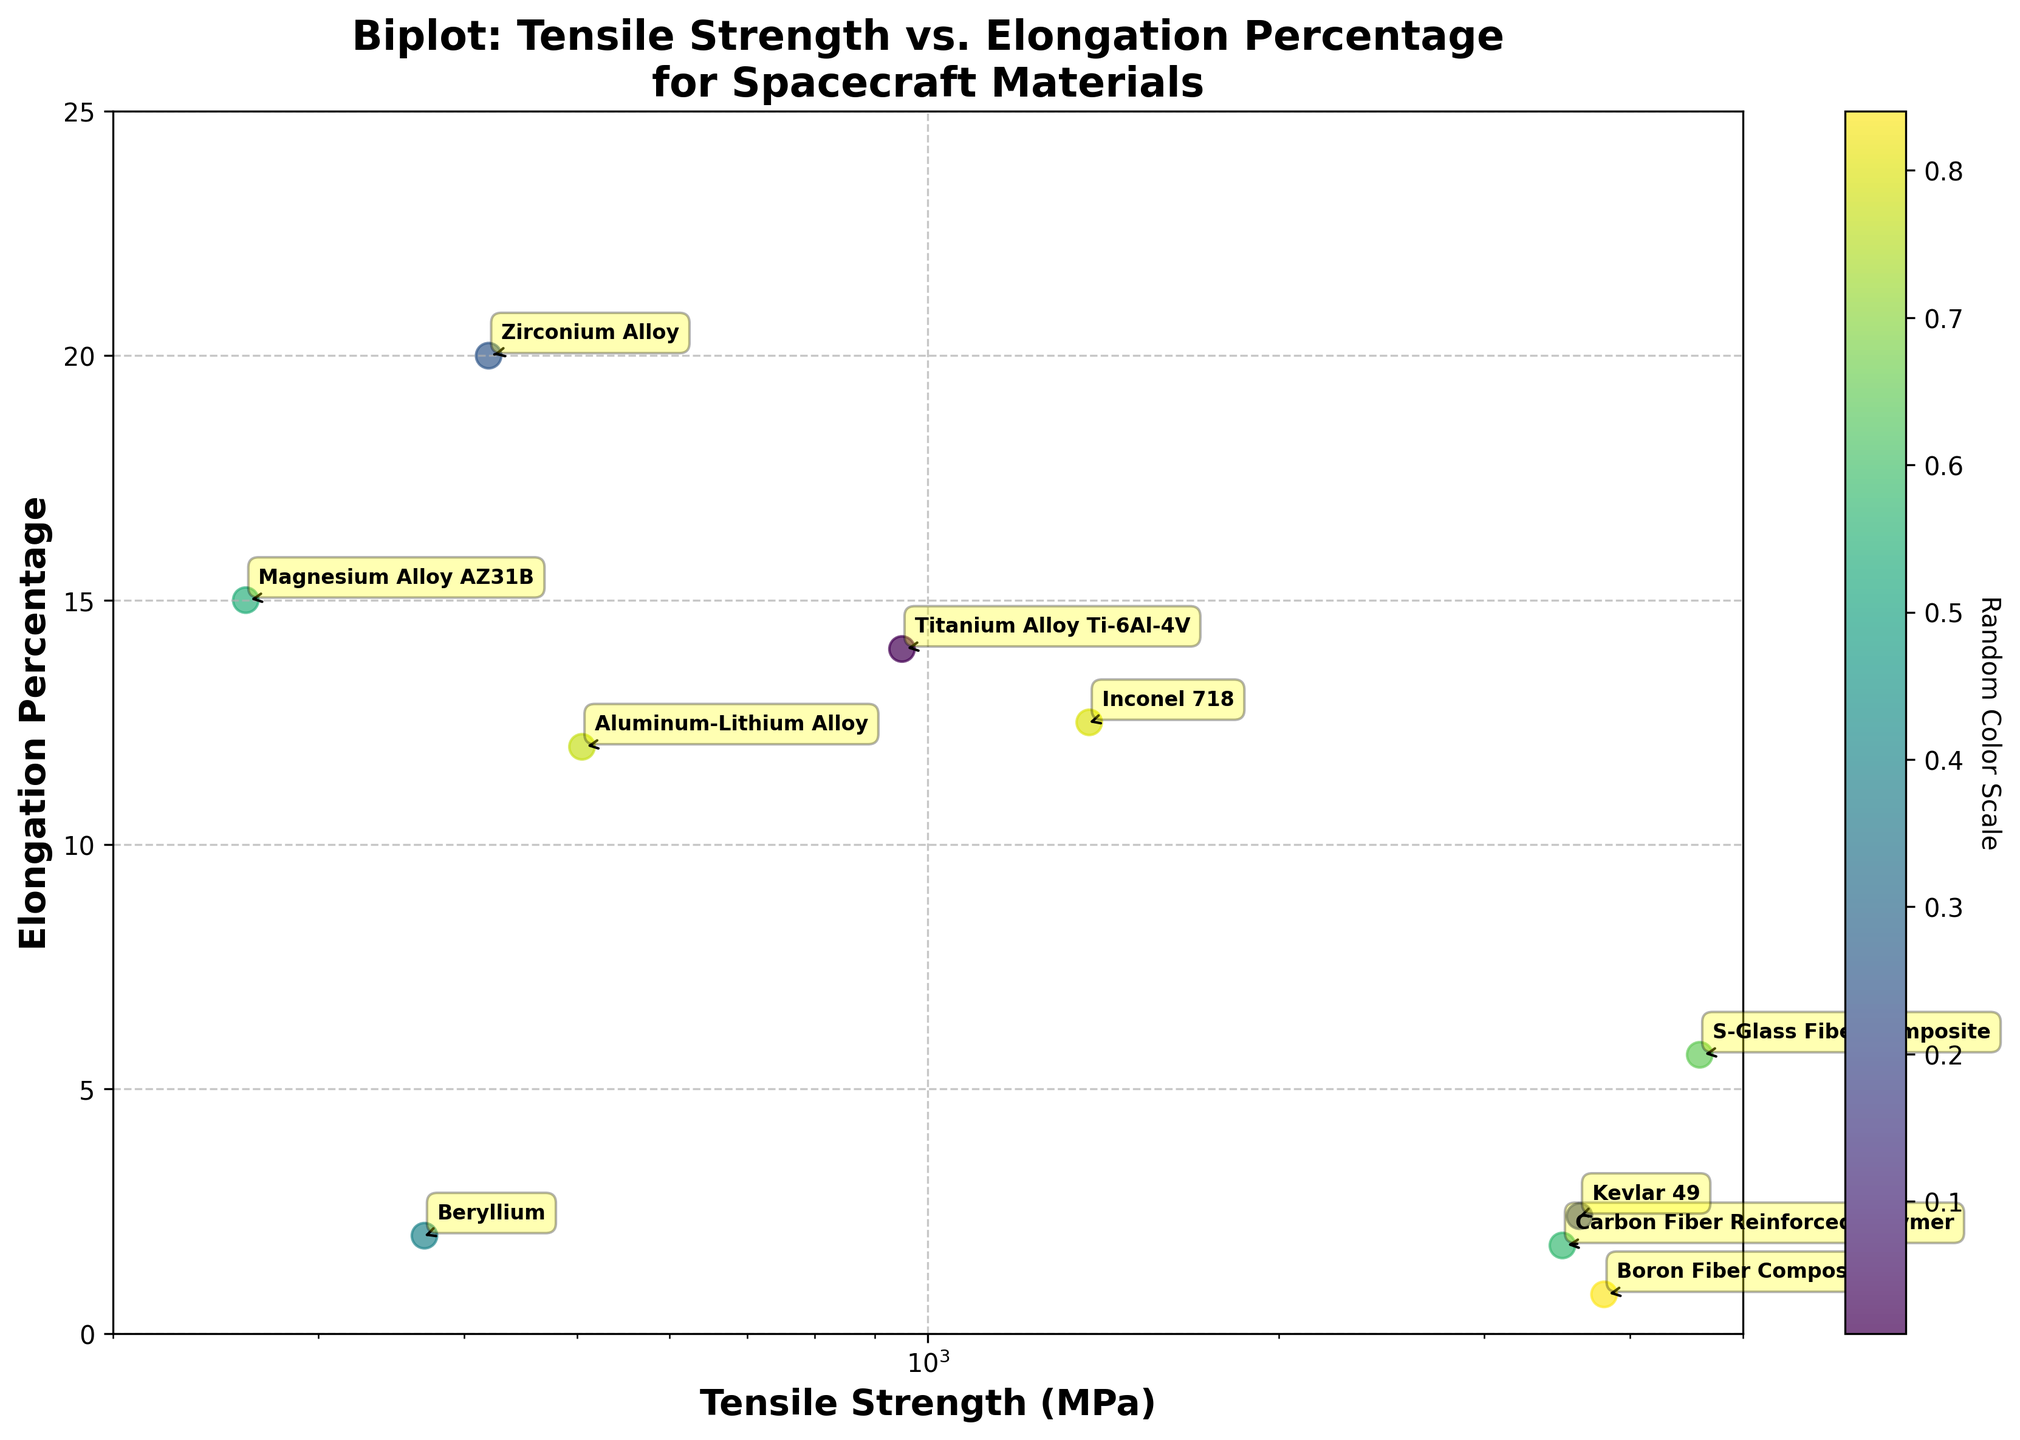Which material has the highest tensile strength? By examining the x-axis (Tensile Strength in MPa), find the data point farthest to the right. The material corresponding to this point has the highest tensile strength.
Answer: S-Glass Fiber Composite Which material has the highest elongation percentage? By examining the y-axis (Elongation Percentage), find the data point that is the highest vertically. The material corresponding to this point has the highest elongation percentage.
Answer: Zirconium Alloy Which material demonstrates the lowest elongation percentage? By examining the y-axis, find the lowest data point. This material has the lowest elongation percentage.
Answer: Boron Fiber Composite What is the title of the figure? Read the title located at the top of the figure.
Answer: Biplot: Tensile Strength vs. Elongation Percentage for Spacecraft Materials How many materials are compared in the figure? Count the number of data points in the scatter plot. This represents the number of materials compared.
Answer: 10 Which materials have an elongation percentage between 10 and 15%? Check the y-axis for points that fall within the 10 to 15% range and read the corresponding material names.
Answer: Aluminum-Lithium Alloy, Titanium Alloy Ti-6Al-4V, Inconel 718 Which materials have a tensile strength over 3000 MPa? Check the x-axis for points that are located beyond 3000 MPa and read the corresponding material names.
Answer: Carbon Fiber Reinforced Polymer, S-Glass Fiber Composite, Kevlar 49, Boron Fiber Composite What is the median tensile strength of all the materials? List all tensile strengths, find the median value. Tensile strengths: [260, 370, 505, 950, 1375, 3500, 3620, 3800, 420, 4590]. The median value is the 6th value when ordered.
Answer: 3500 MPa Which material has approximately the same tensile strength as Inconel 718, but a much lower elongation percentage? Identify the tensile strength of Inconel 718 (1375 MPa) and find another material with a similar tensile strength but a much lower elongation percentage.
Answer: Carbon Fiber Reinforced Polymer What is the average elongation percentage for the materials with tensile strength below 1000 MPa? Identify materials with tensile strength below 1000 MPa: Magnesium Alloy AZ31B (15%), Beryllium (2%), Aluminum-Lithium Alloy (12%), Titanium Alloy Ti-6Al-4V (14%), Zirconium Alloy (20%). Sum the elongation percentages and divide by the number of materials: (15 + 2 + 12 + 14 + 20) / 5.
Answer: 12.6% 